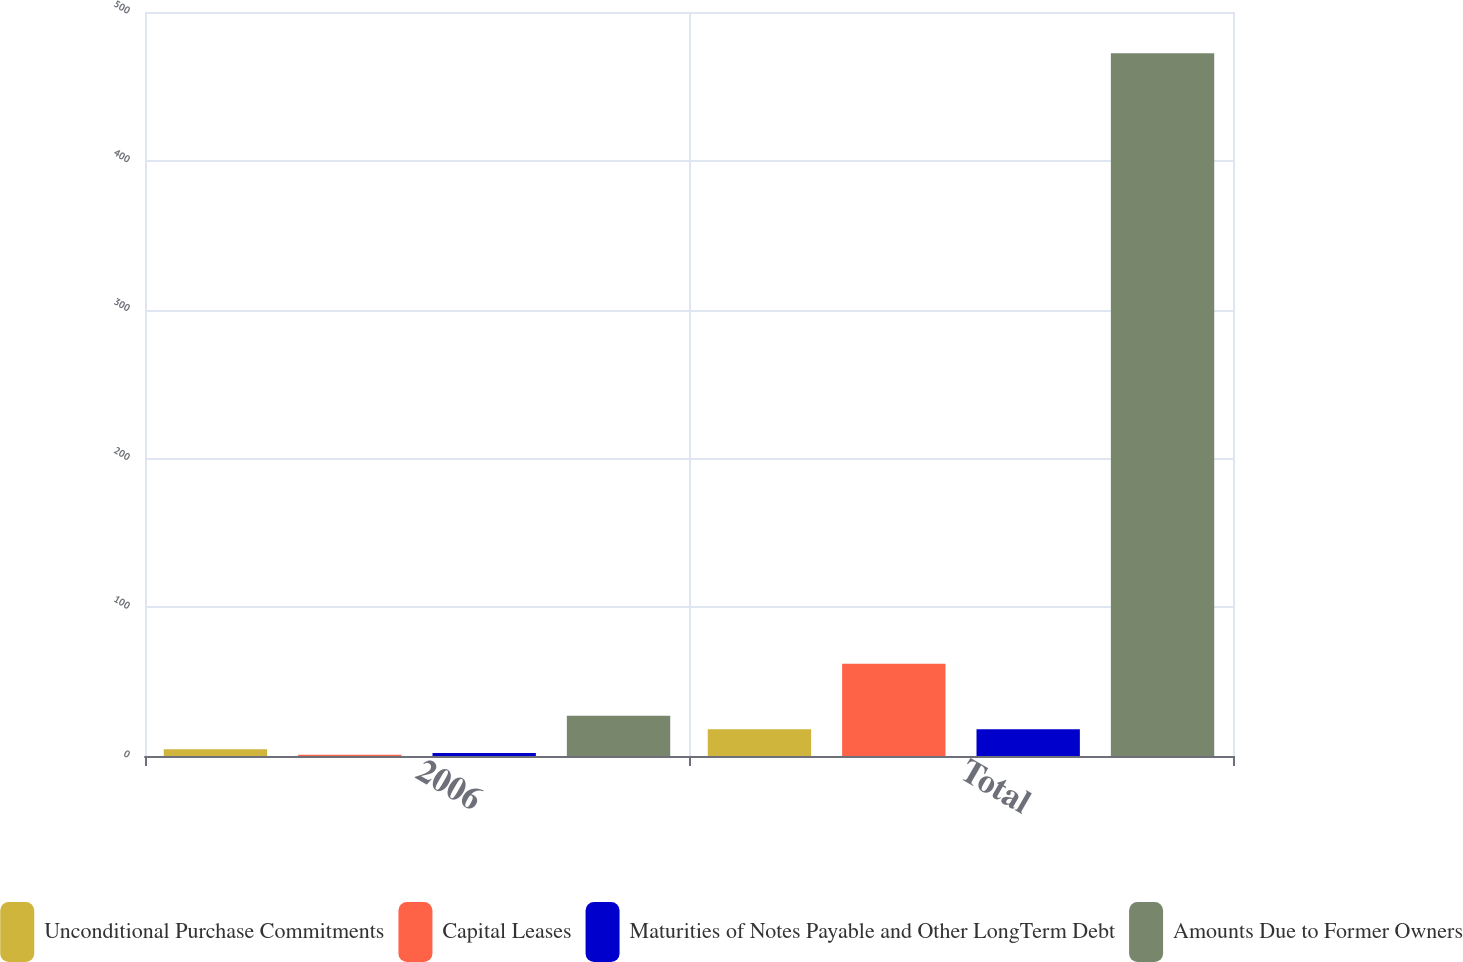<chart> <loc_0><loc_0><loc_500><loc_500><stacked_bar_chart><ecel><fcel>2006<fcel>Total<nl><fcel>Unconditional Purchase Commitments<fcel>4.5<fcel>18<nl><fcel>Capital Leases<fcel>0.9<fcel>62<nl><fcel>Maturities of Notes Payable and Other LongTerm Debt<fcel>2.1<fcel>18<nl><fcel>Amounts Due to Former Owners<fcel>27<fcel>472.3<nl></chart> 